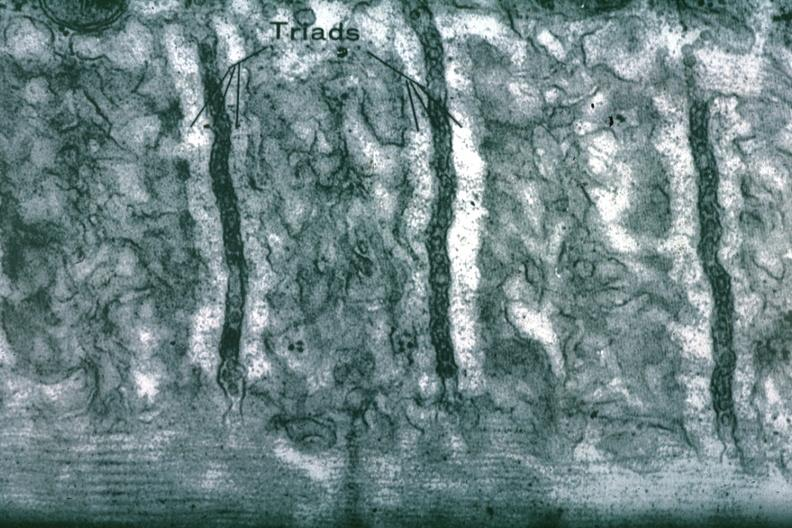does omphalocele show sarcoplasmic reticulum?
Answer the question using a single word or phrase. No 